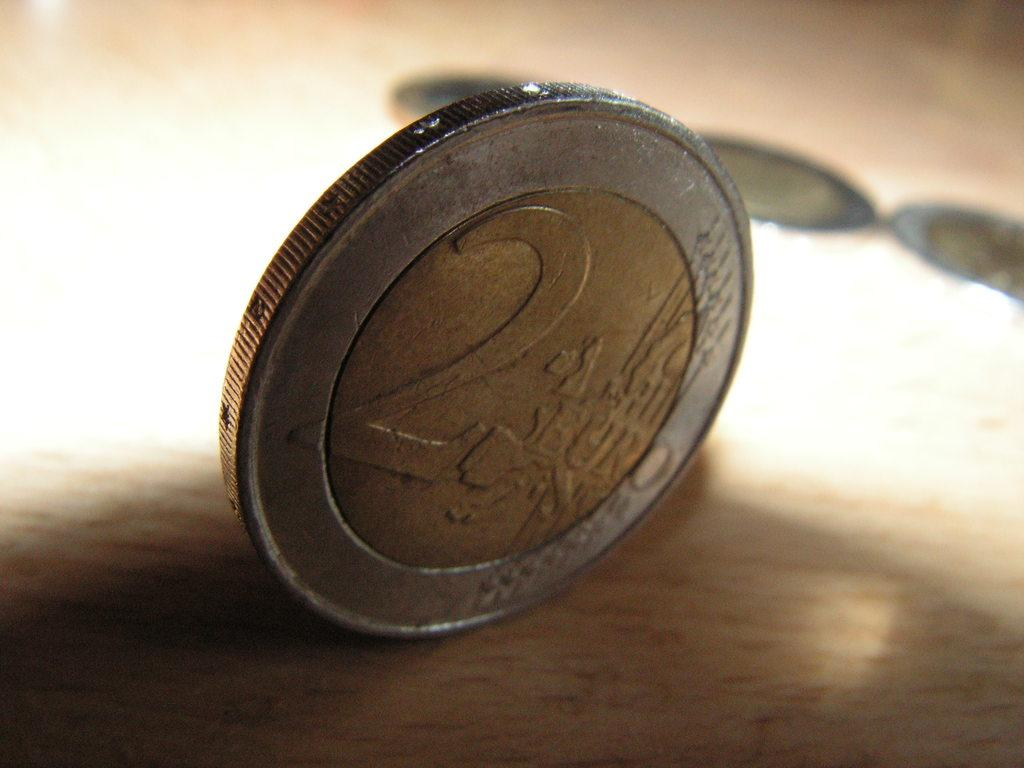<image>
Write a terse but informative summary of the picture. a two euro silver and copper coin sitting on its edge 